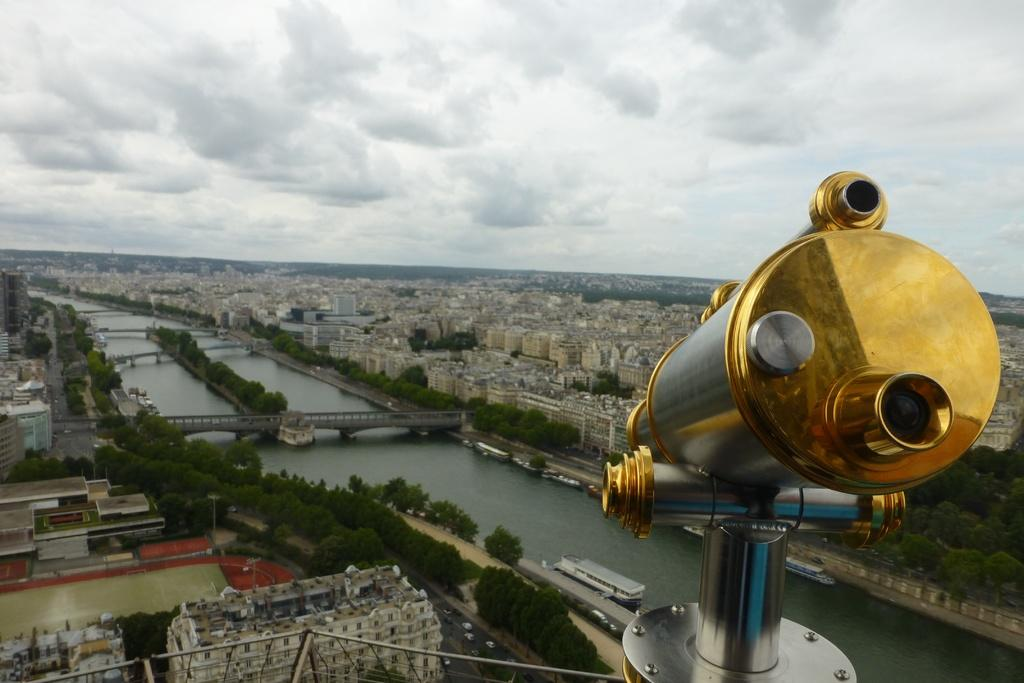What type of view is depicted in the image? The image is an aerial view. What structures can be seen in the image? There are buildings, bridges, and a tower in the image. What type of vegetation is present in the image? There are trees in the image. What is on the water in the image? There are boats on the water in the image. What is visible at the top of the image? The sky is visible at the top of the image. What can be seen in the sky? There are clouds in the sky. What time of day is it in the image, and can you hear the bells ringing? The time of day cannot be determined from the image, and there are no bells present to ring. 